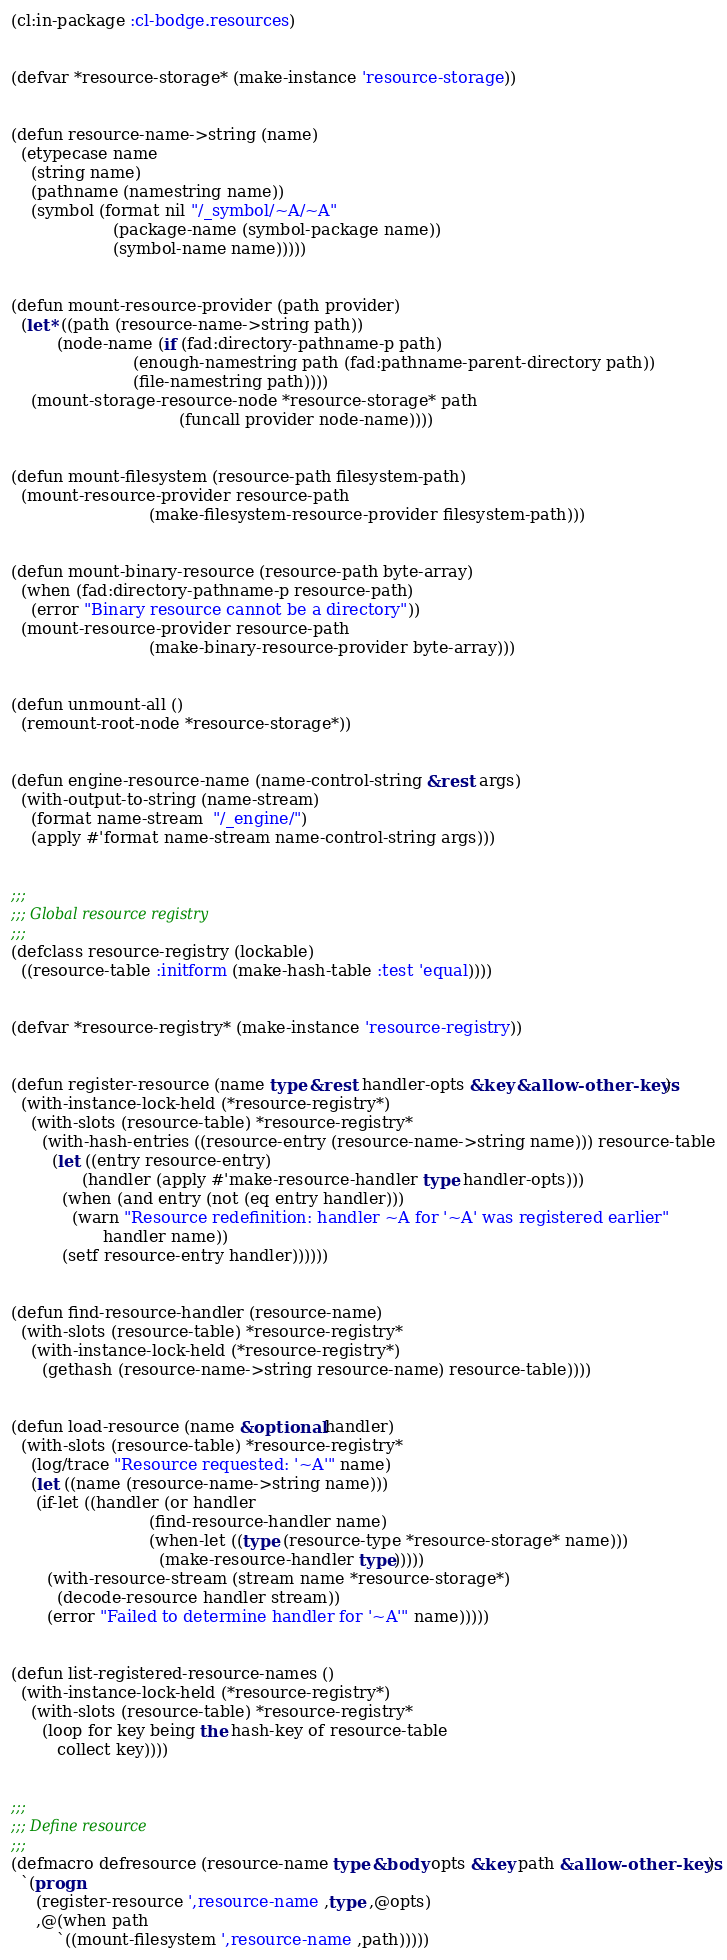Convert code to text. <code><loc_0><loc_0><loc_500><loc_500><_Lisp_>(cl:in-package :cl-bodge.resources)


(defvar *resource-storage* (make-instance 'resource-storage))


(defun resource-name->string (name)
  (etypecase name
    (string name)
    (pathname (namestring name))
    (symbol (format nil "/_symbol/~A/~A"
                    (package-name (symbol-package name))
                    (symbol-name name)))))


(defun mount-resource-provider (path provider)
  (let* ((path (resource-name->string path))
         (node-name (if (fad:directory-pathname-p path)
                        (enough-namestring path (fad:pathname-parent-directory path))
                        (file-namestring path))))
    (mount-storage-resource-node *resource-storage* path
                                 (funcall provider node-name))))


(defun mount-filesystem (resource-path filesystem-path)
  (mount-resource-provider resource-path
                           (make-filesystem-resource-provider filesystem-path)))


(defun mount-binary-resource (resource-path byte-array)
  (when (fad:directory-pathname-p resource-path)
    (error "Binary resource cannot be a directory"))
  (mount-resource-provider resource-path
                           (make-binary-resource-provider byte-array)))


(defun unmount-all ()
  (remount-root-node *resource-storage*))


(defun engine-resource-name (name-control-string &rest args)
  (with-output-to-string (name-stream)
    (format name-stream  "/_engine/")
    (apply #'format name-stream name-control-string args)))


;;;
;;; Global resource registry
;;;
(defclass resource-registry (lockable)
  ((resource-table :initform (make-hash-table :test 'equal))))


(defvar *resource-registry* (make-instance 'resource-registry))


(defun register-resource (name type &rest handler-opts &key &allow-other-keys)
  (with-instance-lock-held (*resource-registry*)
    (with-slots (resource-table) *resource-registry*
      (with-hash-entries ((resource-entry (resource-name->string name))) resource-table
        (let ((entry resource-entry)
              (handler (apply #'make-resource-handler type handler-opts)))
          (when (and entry (not (eq entry handler)))
            (warn "Resource redefinition: handler ~A for '~A' was registered earlier"
                  handler name))
          (setf resource-entry handler))))))


(defun find-resource-handler (resource-name)
  (with-slots (resource-table) *resource-registry*
    (with-instance-lock-held (*resource-registry*)
      (gethash (resource-name->string resource-name) resource-table))))


(defun load-resource (name &optional handler)
  (with-slots (resource-table) *resource-registry*
    (log/trace "Resource requested: '~A'" name)
    (let ((name (resource-name->string name)))
     (if-let ((handler (or handler
                           (find-resource-handler name)
                           (when-let ((type (resource-type *resource-storage* name)))
                             (make-resource-handler type)))))
       (with-resource-stream (stream name *resource-storage*)
         (decode-resource handler stream))
       (error "Failed to determine handler for '~A'" name)))))


(defun list-registered-resource-names ()
  (with-instance-lock-held (*resource-registry*)
    (with-slots (resource-table) *resource-registry*
      (loop for key being the hash-key of resource-table
         collect key))))


;;;
;;; Define resource
;;;
(defmacro defresource (resource-name type &body opts &key path &allow-other-keys)
  `(progn
     (register-resource ',resource-name ,type ,@opts)
     ,@(when path
         `((mount-filesystem ',resource-name ,path)))))
</code> 